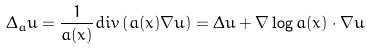<formula> <loc_0><loc_0><loc_500><loc_500>\Delta _ { a } u = \frac { 1 } { a ( x ) } d i v \left ( a ( x ) \nabla u \right ) = \Delta u + \nabla \log a ( x ) \cdot \nabla u</formula> 